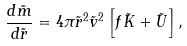<formula> <loc_0><loc_0><loc_500><loc_500>\frac { d \tilde { m } } { d \tilde { r } } = 4 \pi \tilde { r } ^ { 2 } \tilde { v } ^ { 2 } \left [ f \tilde { K } + \tilde { U } \right ] ,</formula> 